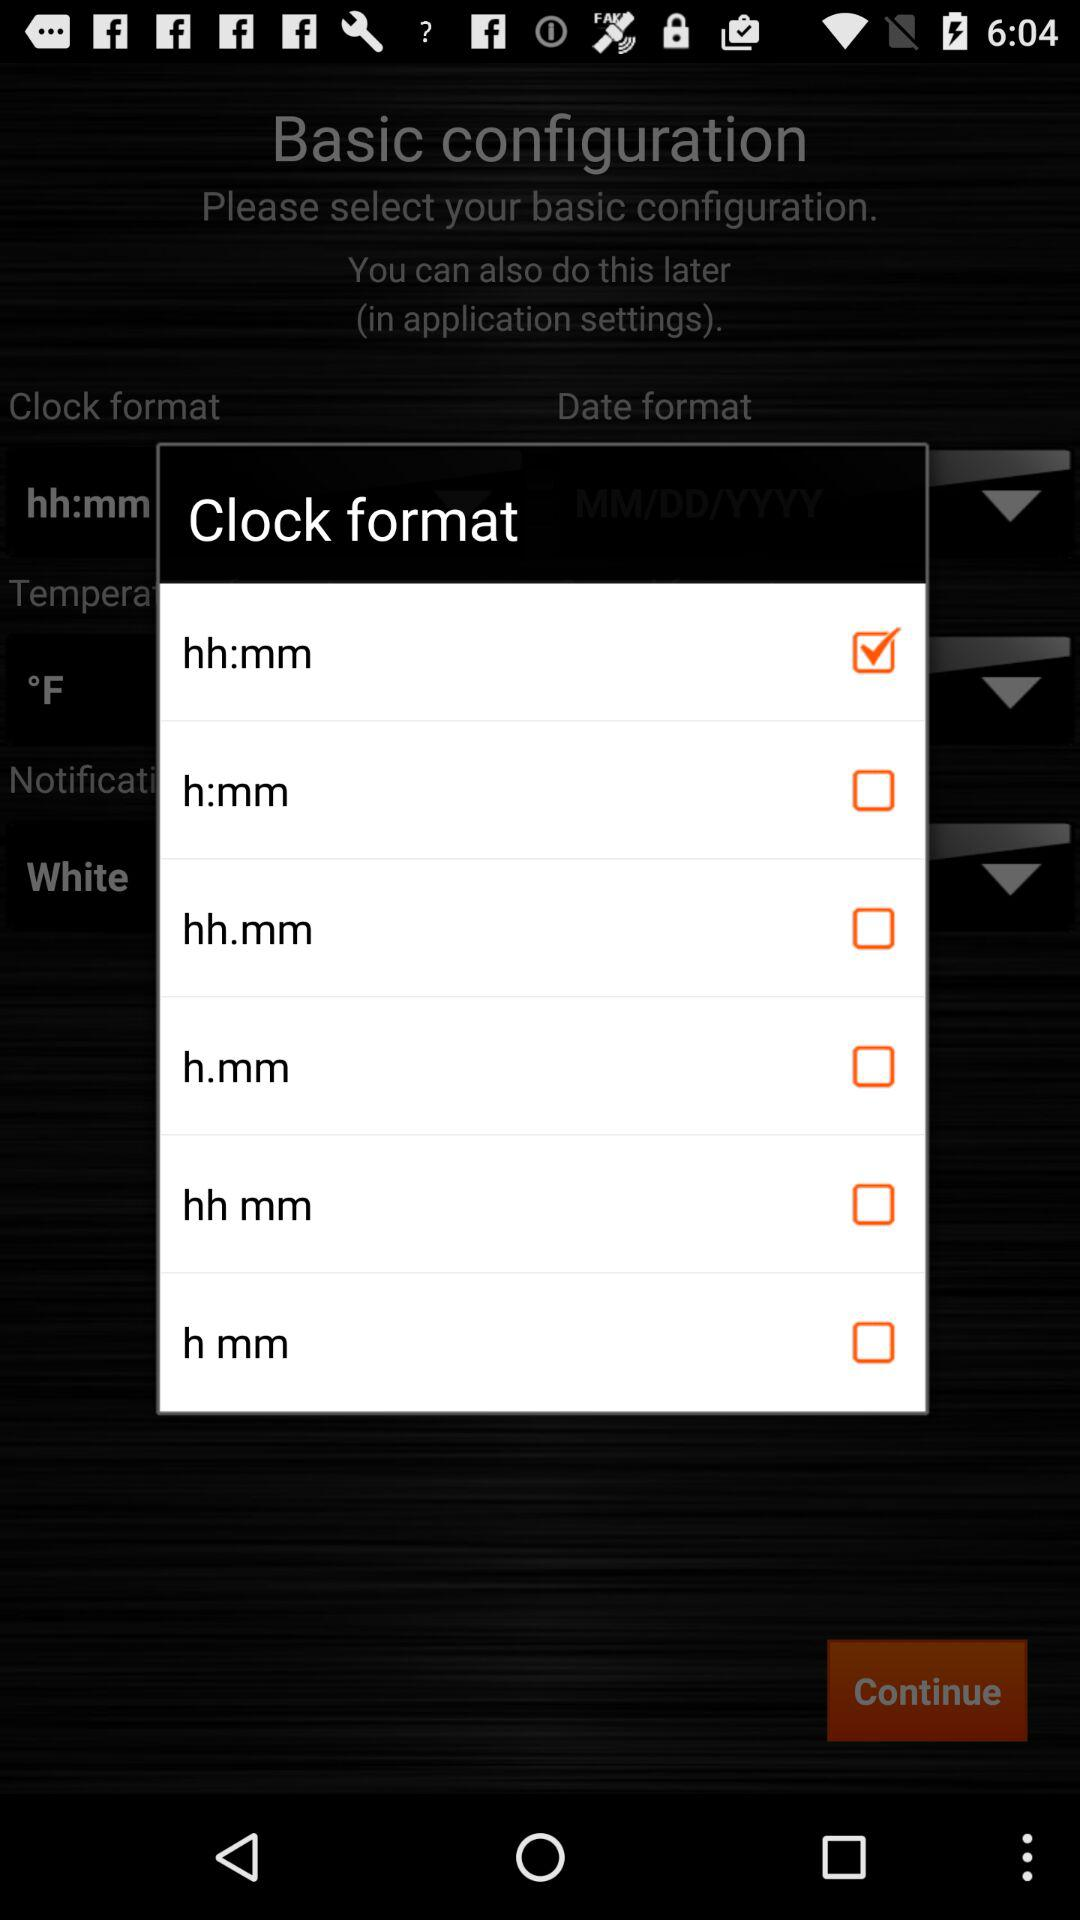What is the status of "h:mm"? The status of "h:mm" is "off". 